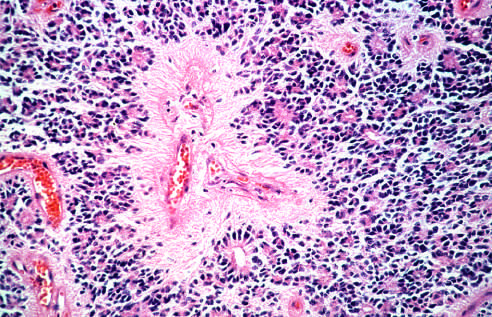what have round nuclei, often with a clear cytoplasmic halo in oligodendroglioma?
Answer the question using a single word or phrase. Tumor cells in oligodendroglioma 